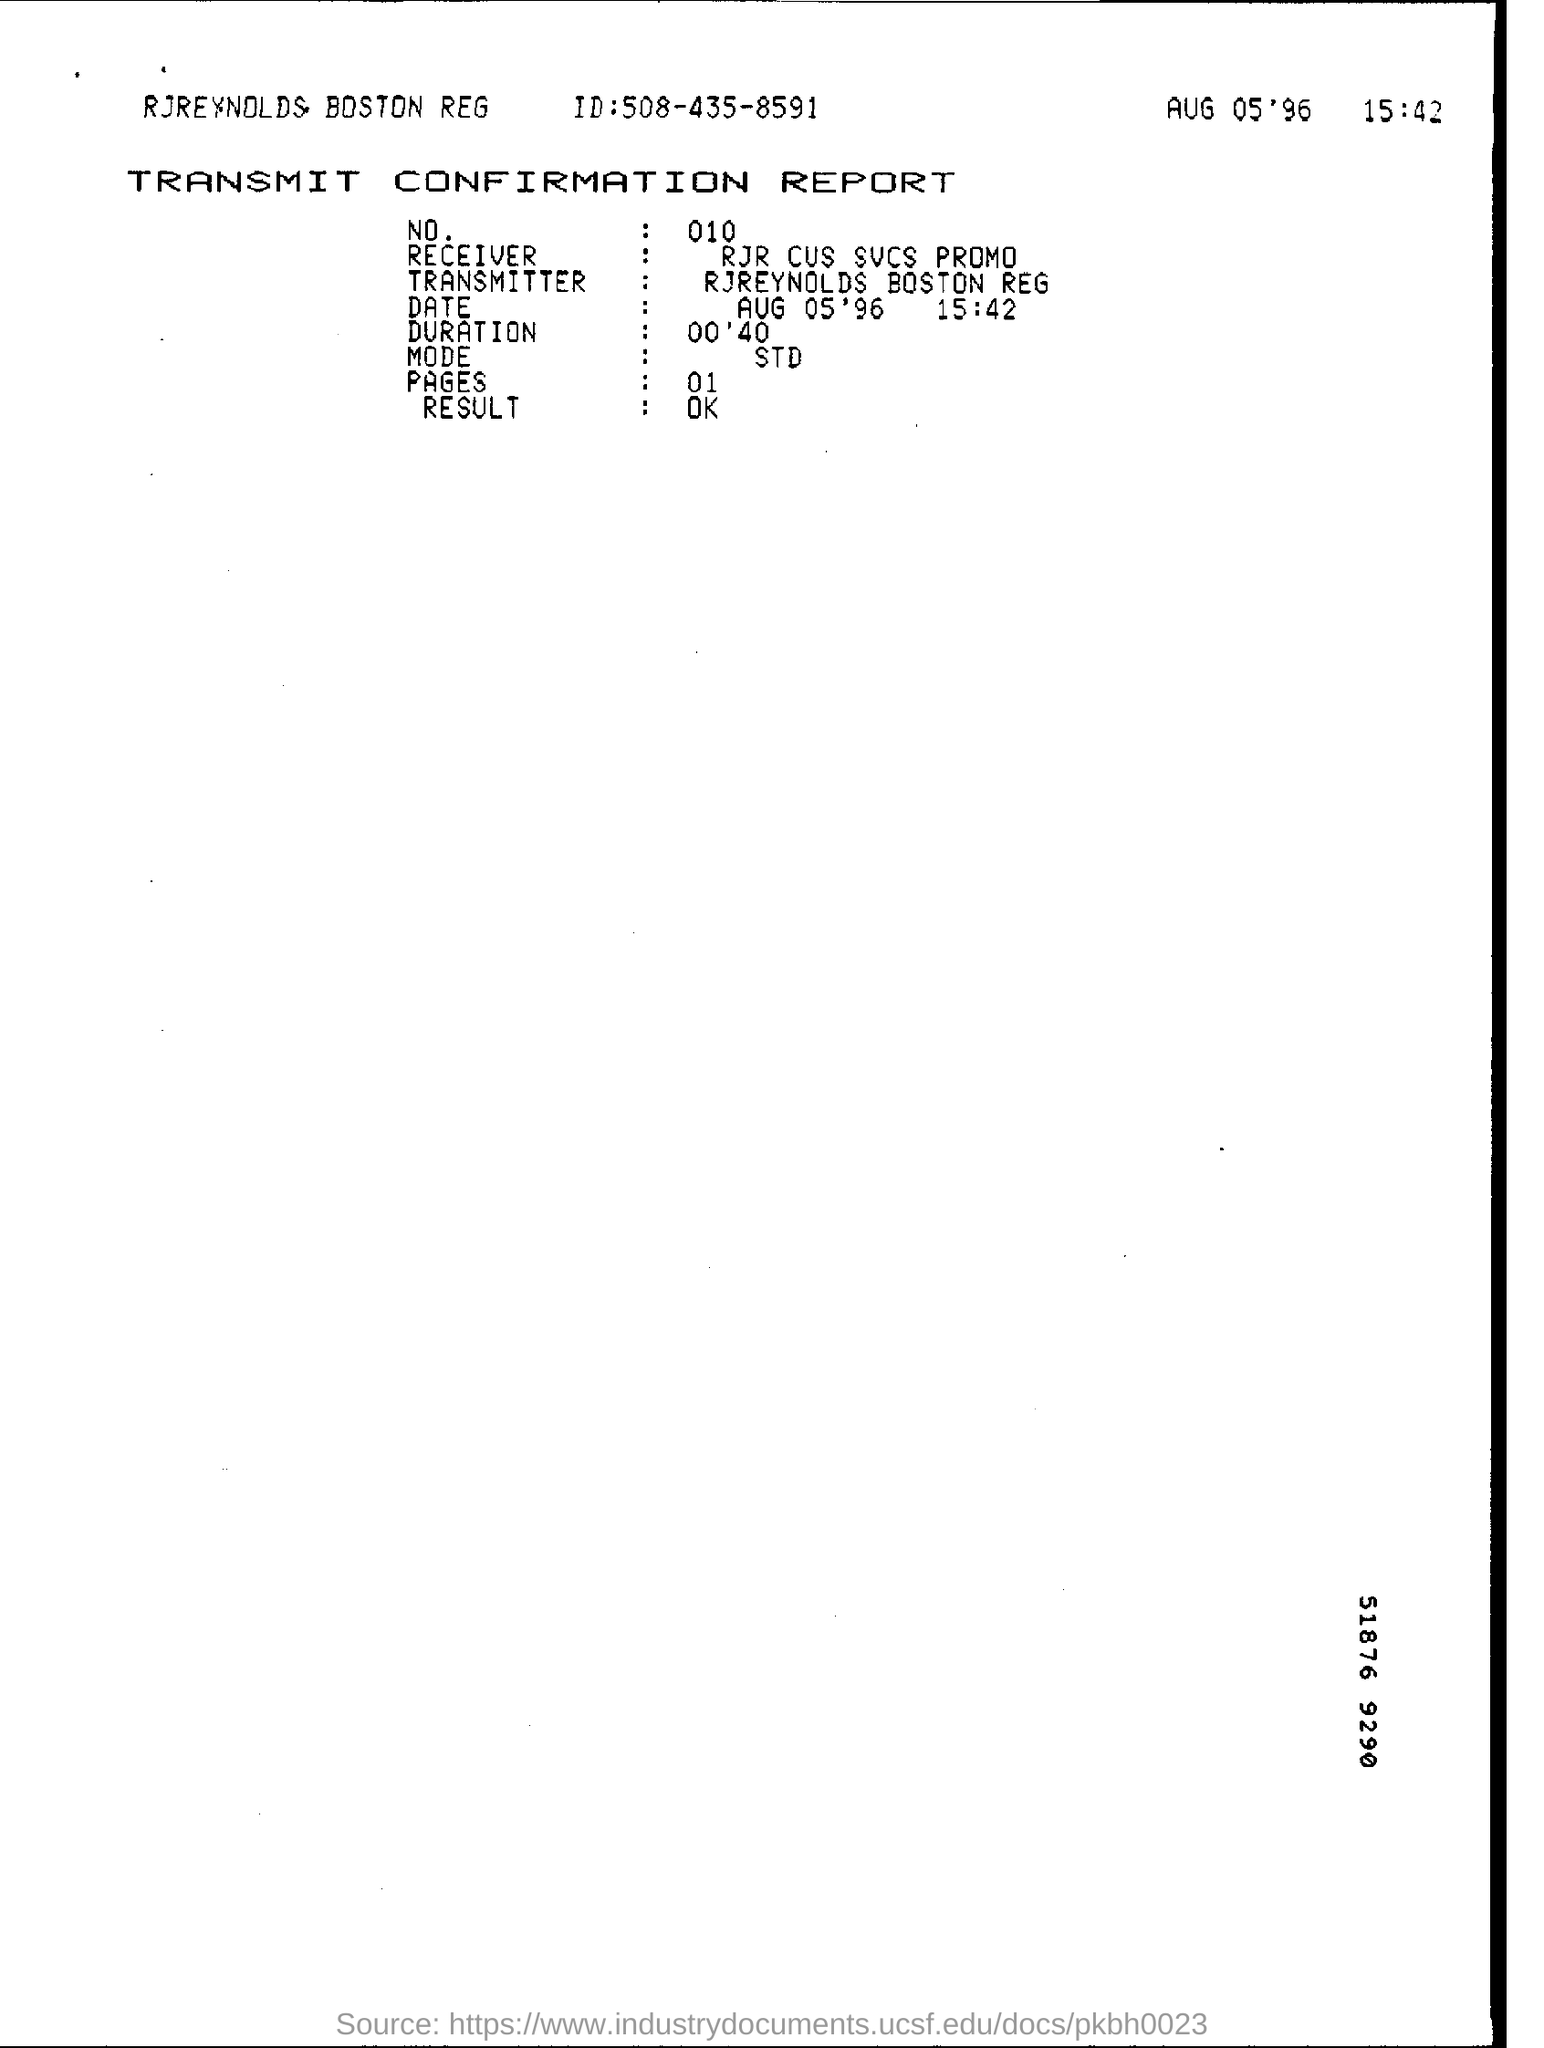How many pages are there in the report ?
Provide a succinct answer. 01. What is the result ?
Make the answer very short. OK. Who is the transmitter ?
Your answer should be very brief. Rjreynolds boston reg. What is the name of the receiver ?
Your answer should be very brief. Rjr cus svcs promo. What is the date mentioned in the report?
Offer a very short reply. Aug 05'96. What is the name of the report ?
Your response must be concise. TRANSMIT CONFIRMATION REPORT. What is the duration mentioned in the report?
Ensure brevity in your answer.  00'40. 